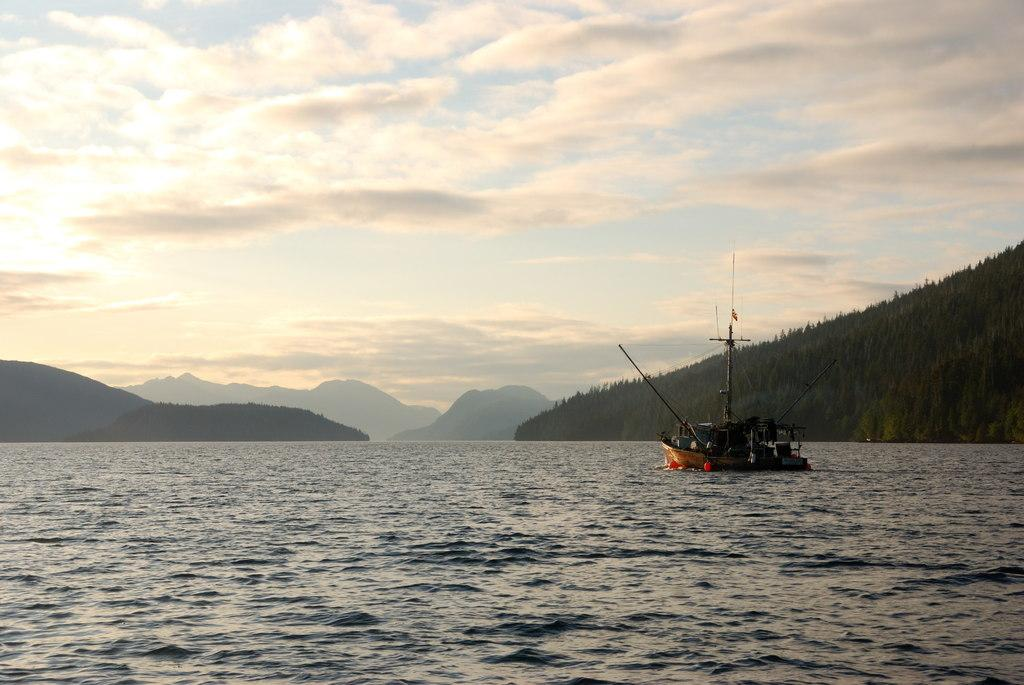What is the main subject of the image? There is a ship in the image. Where is the ship located? The ship is on the water. What can be seen in the background of the image? There are trees and hills in the background of the image. What is visible in the sky at the top of the image? There are clouds visible in the sky at the top of the image. What type of noise can be heard coming from the umbrella in the image? There is no umbrella present in the image, so it is not possible to determine what, if any, noise might be heard. 